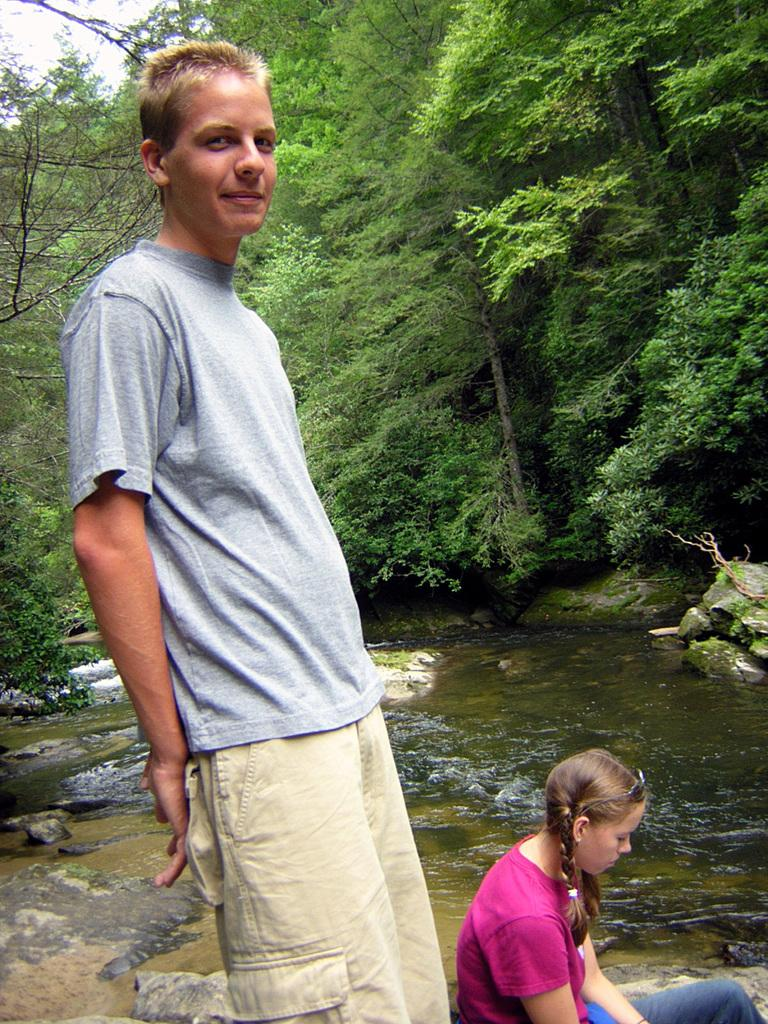What is the man in the image doing? The man is standing in the image and smiling. Who is beside the man in the image? There is a girl beside the man in the image. What type of terrain is visible in the image? Stones and water are present in the image. What can be seen in the background of the image? There are trees in the background of the image. What type of basin is the man using to hold his interest in the image? There is no basin or indication of any interest-related activity in the image; it simply shows a man standing with a girl beside him, surrounded by stones and water, with trees in the background. 